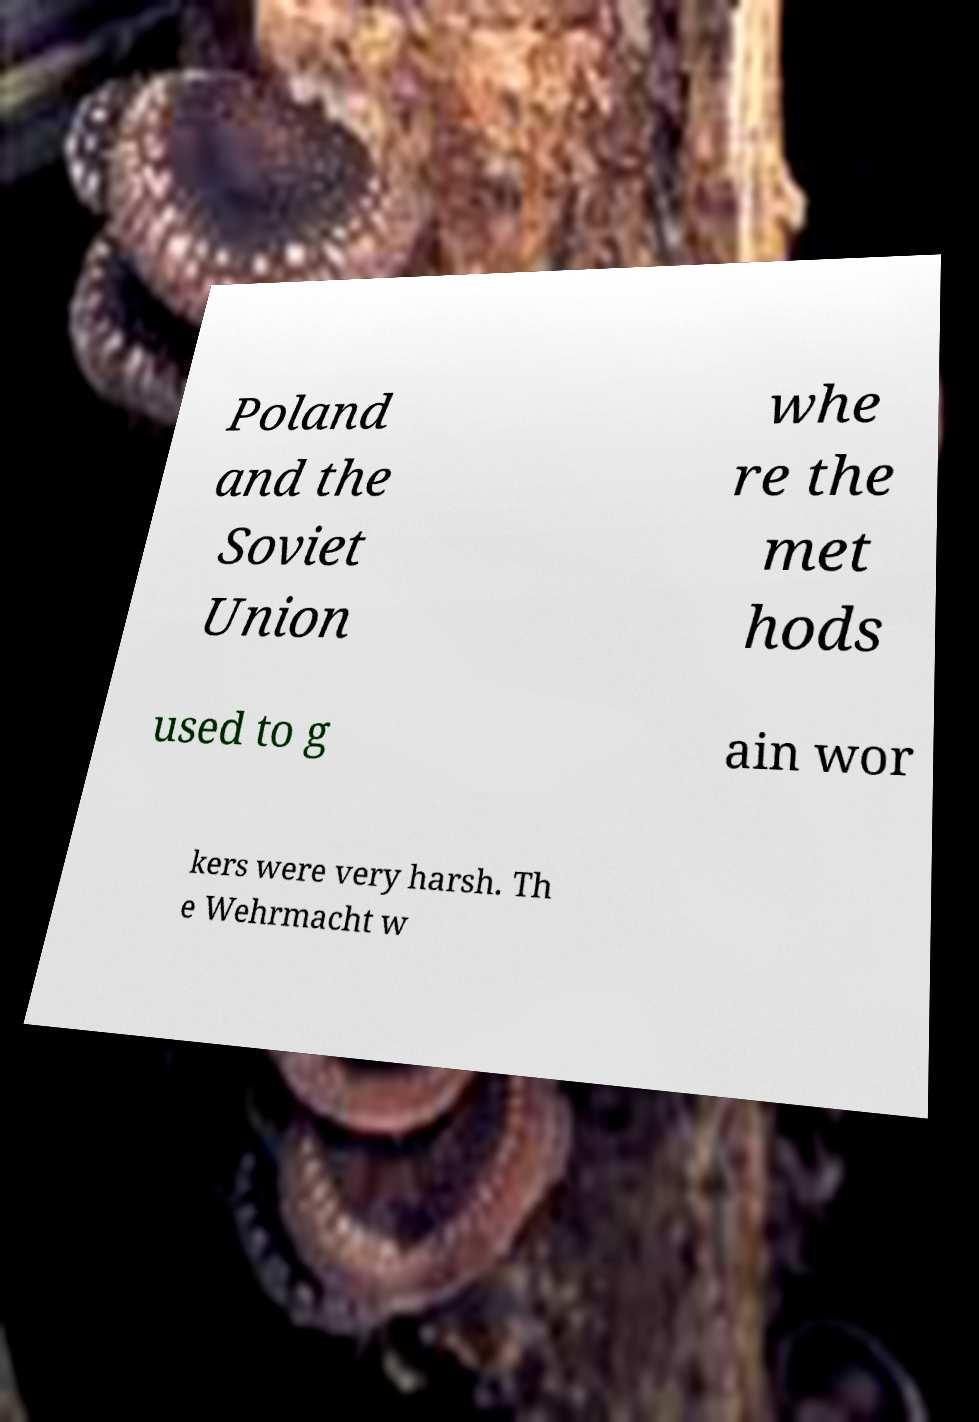What messages or text are displayed in this image? I need them in a readable, typed format. Poland and the Soviet Union whe re the met hods used to g ain wor kers were very harsh. Th e Wehrmacht w 